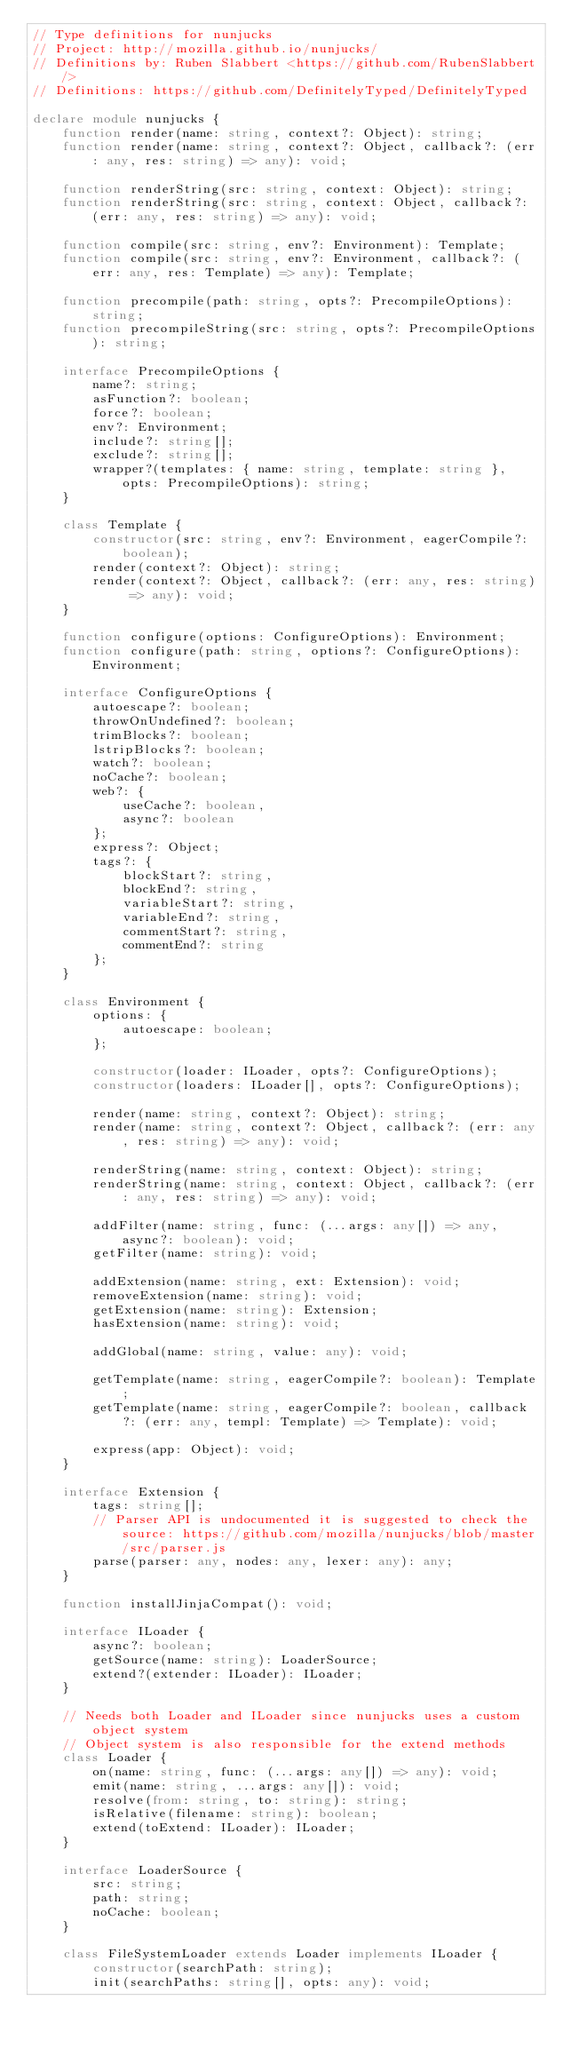Convert code to text. <code><loc_0><loc_0><loc_500><loc_500><_TypeScript_>// Type definitions for nunjucks
// Project: http://mozilla.github.io/nunjucks/
// Definitions by: Ruben Slabbert <https://github.com/RubenSlabbert/>
// Definitions: https://github.com/DefinitelyTyped/DefinitelyTyped

declare module nunjucks {
    function render(name: string, context?: Object): string;
    function render(name: string, context?: Object, callback?: (err: any, res: string) => any): void;

    function renderString(src: string, context: Object): string;
    function renderString(src: string, context: Object, callback?: (err: any, res: string) => any): void;

    function compile(src: string, env?: Environment): Template;
    function compile(src: string, env?: Environment, callback?: (err: any, res: Template) => any): Template;

    function precompile(path: string, opts?: PrecompileOptions): string;
    function precompileString(src: string, opts?: PrecompileOptions): string;

    interface PrecompileOptions {
        name?: string;
        asFunction?: boolean;
        force?: boolean;
        env?: Environment;
        include?: string[];
        exclude?: string[];
        wrapper?(templates: { name: string, template: string }, opts: PrecompileOptions): string;
    }

    class Template {
        constructor(src: string, env?: Environment, eagerCompile?: boolean);
        render(context?: Object): string;
        render(context?: Object, callback?: (err: any, res: string) => any): void;
    }

    function configure(options: ConfigureOptions): Environment;
    function configure(path: string, options?: ConfigureOptions): Environment;

    interface ConfigureOptions {
        autoescape?: boolean;
        throwOnUndefined?: boolean;
        trimBlocks?: boolean;
        lstripBlocks?: boolean;
        watch?: boolean;
        noCache?: boolean;
        web?: {
            useCache?: boolean,
            async?: boolean
        };
        express?: Object;
        tags?: {
            blockStart?: string,
            blockEnd?: string,
            variableStart?: string,
            variableEnd?: string,
            commentStart?: string,
            commentEnd?: string
        };
    }

    class Environment {
        options: {
            autoescape: boolean;
        };

        constructor(loader: ILoader, opts?: ConfigureOptions);
        constructor(loaders: ILoader[], opts?: ConfigureOptions);

        render(name: string, context?: Object): string;
        render(name: string, context?: Object, callback?: (err: any, res: string) => any): void;

        renderString(name: string, context: Object): string;
        renderString(name: string, context: Object, callback?: (err: any, res: string) => any): void;

        addFilter(name: string, func: (...args: any[]) => any, async?: boolean): void;
        getFilter(name: string): void;

        addExtension(name: string, ext: Extension): void;
        removeExtension(name: string): void;
        getExtension(name: string): Extension;
        hasExtension(name: string): void;

        addGlobal(name: string, value: any): void;

        getTemplate(name: string, eagerCompile?: boolean): Template;
        getTemplate(name: string, eagerCompile?: boolean, callback?: (err: any, templ: Template) => Template): void;

        express(app: Object): void;
    }

    interface Extension {
        tags: string[];
        // Parser API is undocumented it is suggested to check the source: https://github.com/mozilla/nunjucks/blob/master/src/parser.js
        parse(parser: any, nodes: any, lexer: any): any;
    }

    function installJinjaCompat(): void;

    interface ILoader {
        async?: boolean;
        getSource(name: string): LoaderSource;
        extend?(extender: ILoader): ILoader;
    }

    // Needs both Loader and ILoader since nunjucks uses a custom object system
    // Object system is also responsible for the extend methods
    class Loader {
        on(name: string, func: (...args: any[]) => any): void;
        emit(name: string, ...args: any[]): void;
        resolve(from: string, to: string): string;
        isRelative(filename: string): boolean;
        extend(toExtend: ILoader): ILoader;
    }

    interface LoaderSource {
        src: string;
        path: string;
        noCache: boolean;
    }

    class FileSystemLoader extends Loader implements ILoader {
        constructor(searchPath: string);
        init(searchPaths: string[], opts: any): void;</code> 